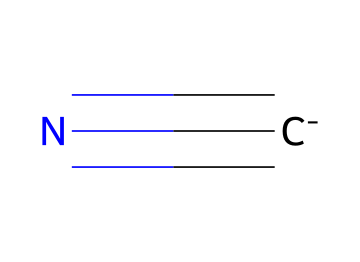What is the chemical formula represented by this SMILES notation? The SMILES notation [C-]#N indicates that the chemical has a carbon atom bonded to a nitrogen atom in a triple bond, and the carbon carries a negative charge. Thus, the chemical formula for this structure is CN.
Answer: CN How many total atoms are present in this molecule? The molecule consists of one carbon atom and one nitrogen atom, totaling two atoms.
Answer: 2 What type of bonding is present in this chemical structure? The notation "#N" indicates a triple bond between carbon and nitrogen, representing the strong triple bonding characteristic of nitriles.
Answer: triple bond Which element in this compound can be used as a precursor for chemical weapons? Cyanide, as part of the nitrile family, is known for its toxicity and has been considered as a precursor for chemical weapons, particularly due to the presence of the carbon and nitrogen atoms.
Answer: cyanide Is this compound acidic or basic? Nitriles, including cyanide, are considered neutral and non-proton accepting, indicating that they are neither acidic nor basic in solution.
Answer: neutral What type of chemical is represented by the structure in the SMILES notation? The structure described in the SMILES notation [C-]#N represents a nitrile, which is characterized by a carbon atom bonded to a nitrogen atom through a triple bond.
Answer: nitrile 